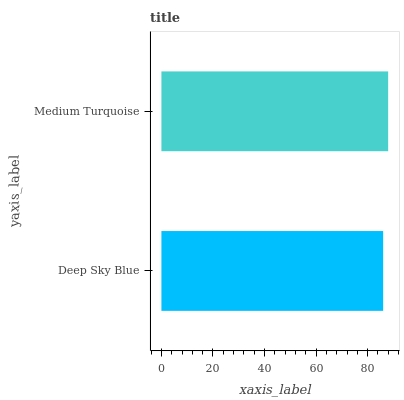Is Deep Sky Blue the minimum?
Answer yes or no. Yes. Is Medium Turquoise the maximum?
Answer yes or no. Yes. Is Medium Turquoise the minimum?
Answer yes or no. No. Is Medium Turquoise greater than Deep Sky Blue?
Answer yes or no. Yes. Is Deep Sky Blue less than Medium Turquoise?
Answer yes or no. Yes. Is Deep Sky Blue greater than Medium Turquoise?
Answer yes or no. No. Is Medium Turquoise less than Deep Sky Blue?
Answer yes or no. No. Is Medium Turquoise the high median?
Answer yes or no. Yes. Is Deep Sky Blue the low median?
Answer yes or no. Yes. Is Deep Sky Blue the high median?
Answer yes or no. No. Is Medium Turquoise the low median?
Answer yes or no. No. 